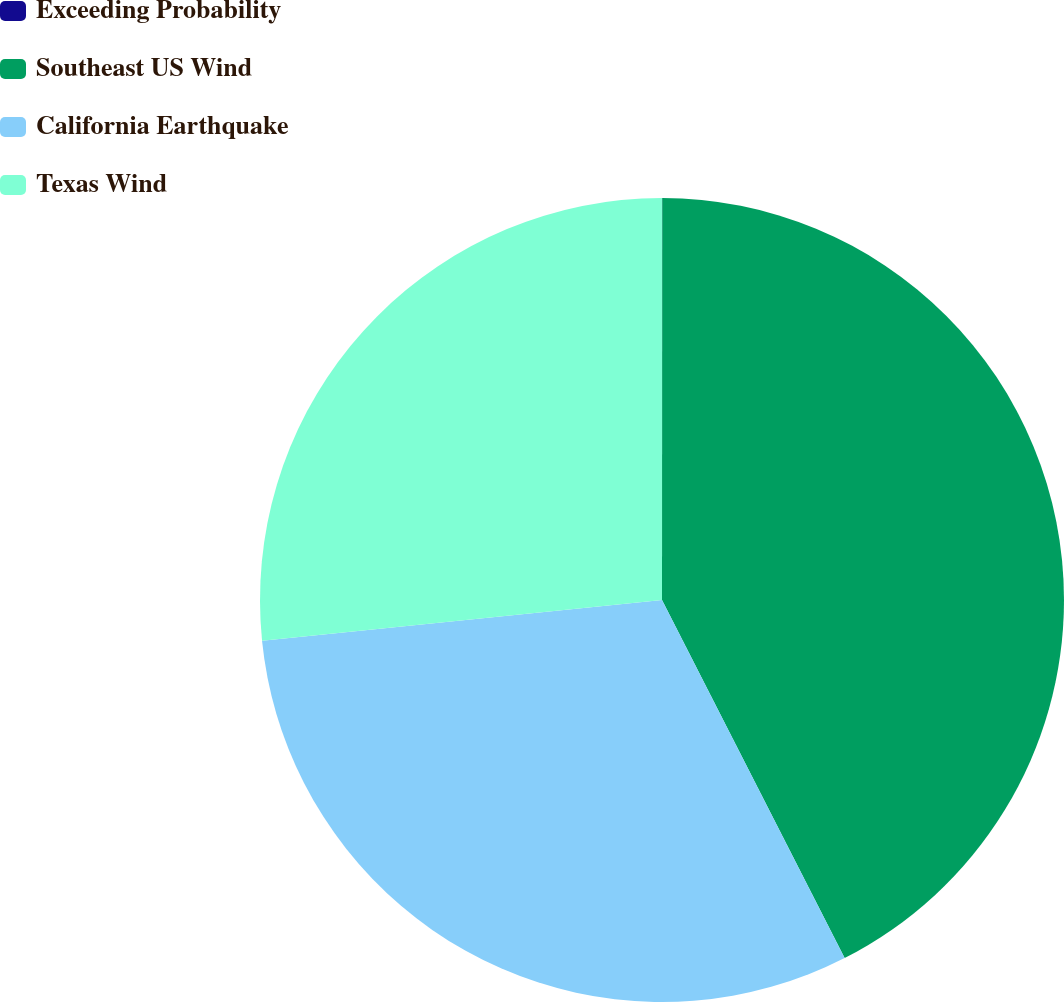Convert chart. <chart><loc_0><loc_0><loc_500><loc_500><pie_chart><fcel>Exceeding Probability<fcel>Southeast US Wind<fcel>California Earthquake<fcel>Texas Wind<nl><fcel>0.01%<fcel>42.48%<fcel>30.89%<fcel>26.61%<nl></chart> 